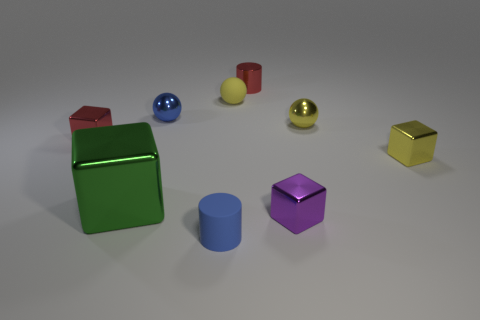Is there any other thing that is the same size as the green thing?
Provide a succinct answer. No. Does the matte sphere have the same color as the shiny sphere on the right side of the purple cube?
Your response must be concise. Yes. What is the shape of the thing that is the same color as the small rubber cylinder?
Your answer should be very brief. Sphere. There is a tiny purple block to the right of the tiny cylinder that is in front of the red thing that is left of the large green metal block; what is its material?
Make the answer very short. Metal. Does the red metal thing that is in front of the red cylinder have the same shape as the purple thing?
Keep it short and to the point. Yes. What is the small cube behind the small yellow block made of?
Offer a very short reply. Metal. How many matte things are either cyan objects or green cubes?
Your response must be concise. 0. Are there any other blue rubber cylinders that have the same size as the blue cylinder?
Ensure brevity in your answer.  No. Are there more small cubes behind the large green object than tiny yellow matte things?
Ensure brevity in your answer.  Yes. How many small objects are either blue metal things or red cylinders?
Offer a terse response. 2. 